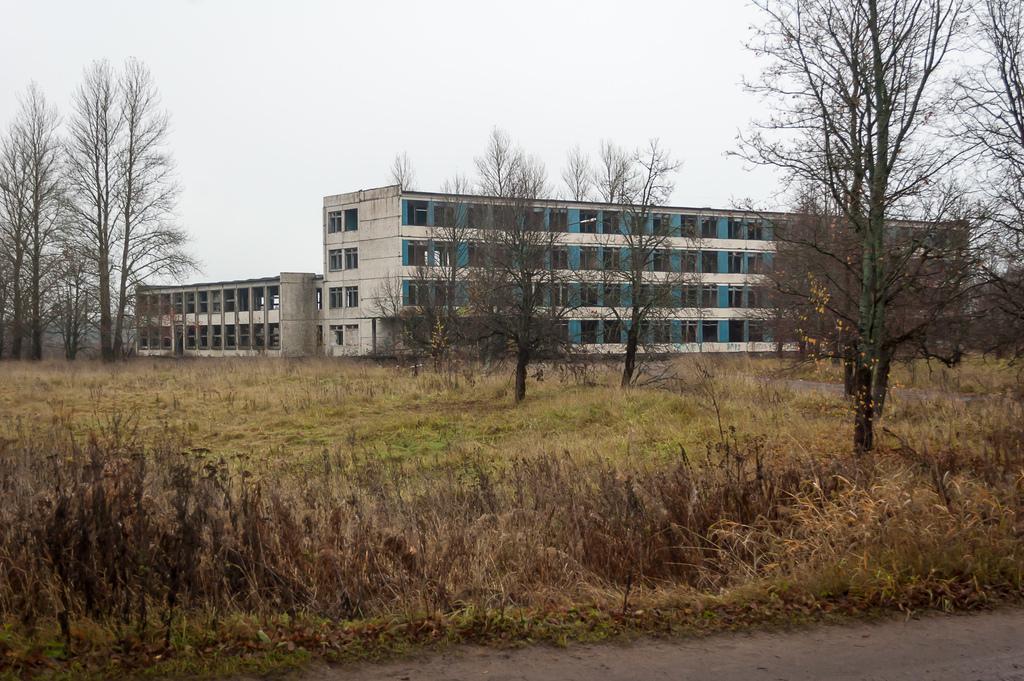Describe this image in one or two sentences. In this image there is the sky towards the top of the image, there are buildings, there are windows, there are trees towards the right of the image, there are trees towards the left of the image, there is grass, there are plants, there is ground towards the bottom of the image. 